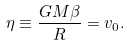Convert formula to latex. <formula><loc_0><loc_0><loc_500><loc_500>\eta \equiv \frac { G M \beta } { R } = v _ { 0 } .</formula> 